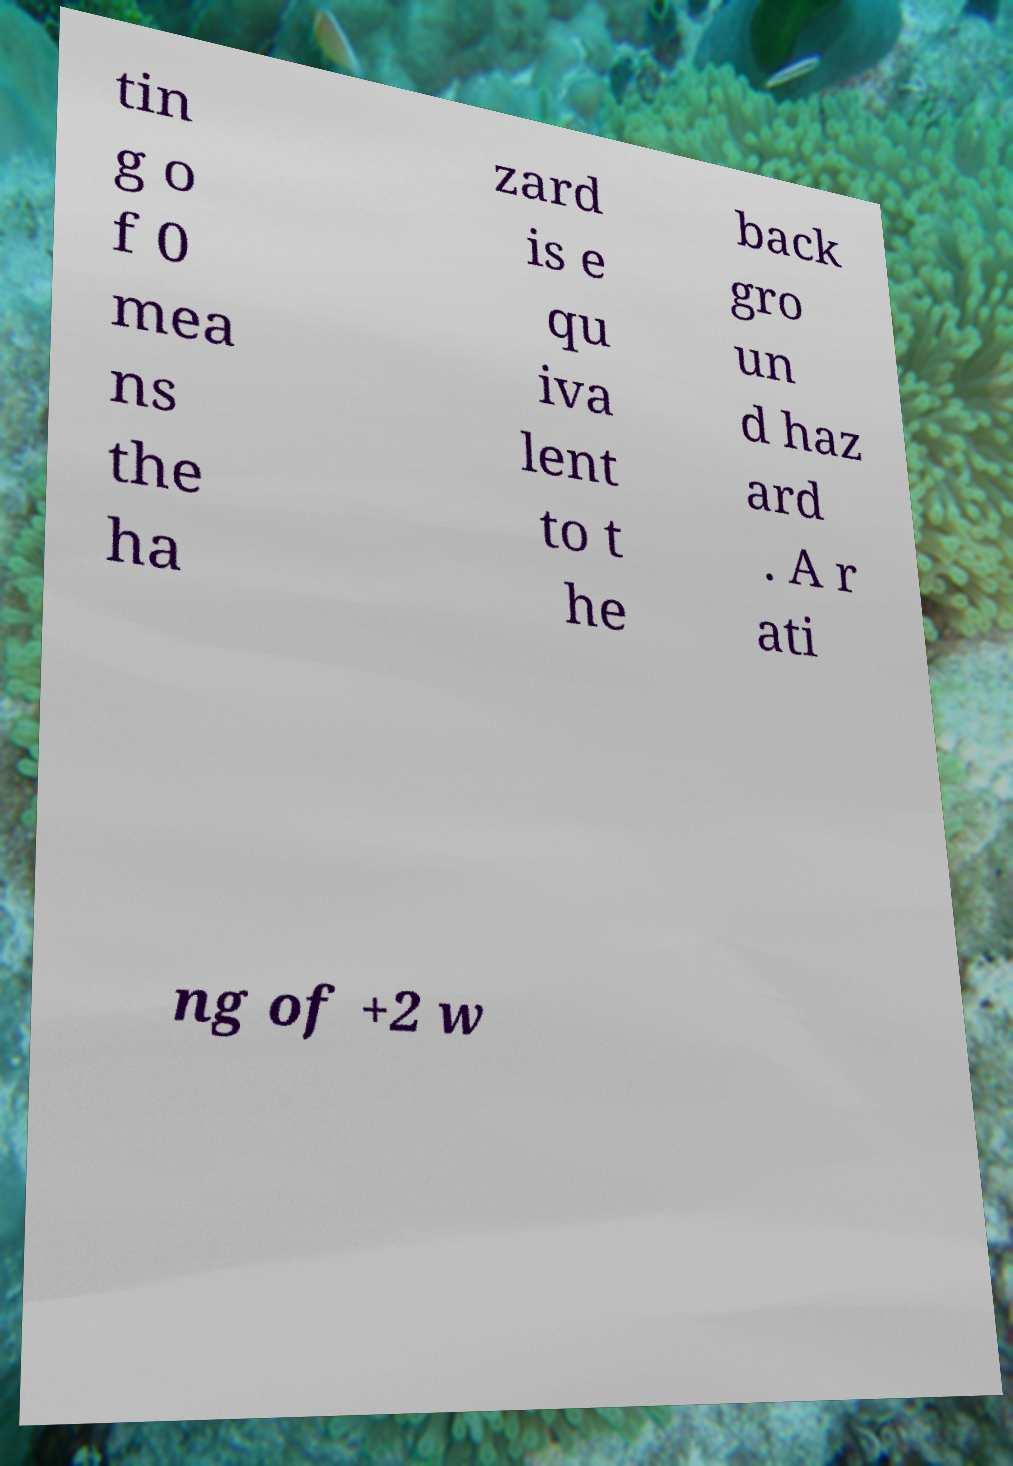There's text embedded in this image that I need extracted. Can you transcribe it verbatim? tin g o f 0 mea ns the ha zard is e qu iva lent to t he back gro un d haz ard . A r ati ng of +2 w 